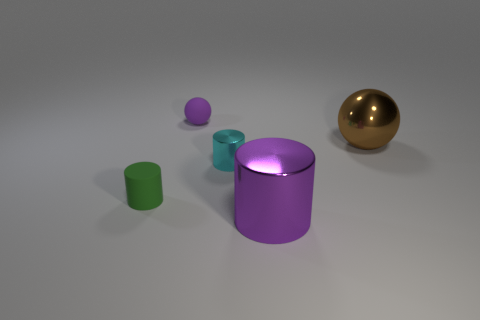Subtract all big cylinders. How many cylinders are left? 2 Subtract all cylinders. How many objects are left? 2 Add 3 green cylinders. How many objects exist? 8 Subtract all purple balls. How many balls are left? 1 Add 2 purple metal things. How many purple metal things exist? 3 Subtract 1 brown spheres. How many objects are left? 4 Subtract 3 cylinders. How many cylinders are left? 0 Subtract all purple cylinders. Subtract all red cubes. How many cylinders are left? 2 Subtract all gray balls. How many green cylinders are left? 1 Subtract all small brown objects. Subtract all tiny green things. How many objects are left? 4 